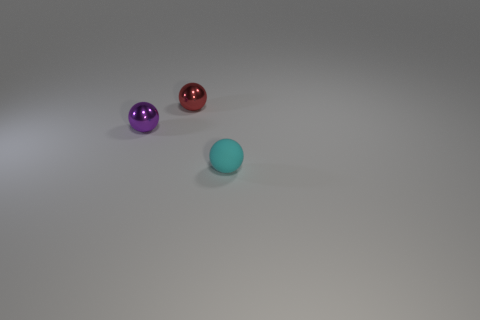Add 3 large purple cubes. How many objects exist? 6 Subtract all purple metallic objects. Subtract all tiny red shiny cylinders. How many objects are left? 2 Add 1 red balls. How many red balls are left? 2 Add 1 blue things. How many blue things exist? 1 Subtract 0 gray cylinders. How many objects are left? 3 